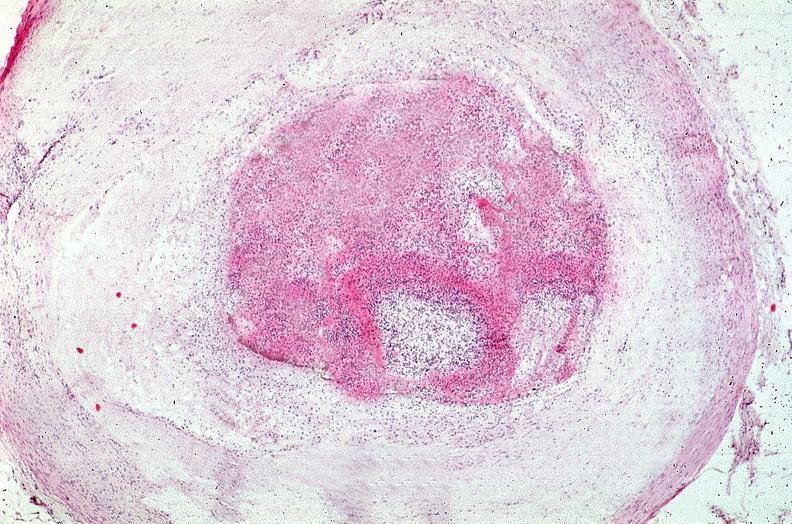where is this from?
Answer the question using a single word or phrase. Vasculature 